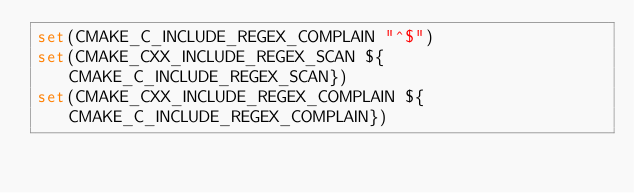Convert code to text. <code><loc_0><loc_0><loc_500><loc_500><_CMake_>set(CMAKE_C_INCLUDE_REGEX_COMPLAIN "^$")
set(CMAKE_CXX_INCLUDE_REGEX_SCAN ${CMAKE_C_INCLUDE_REGEX_SCAN})
set(CMAKE_CXX_INCLUDE_REGEX_COMPLAIN ${CMAKE_C_INCLUDE_REGEX_COMPLAIN})
</code> 